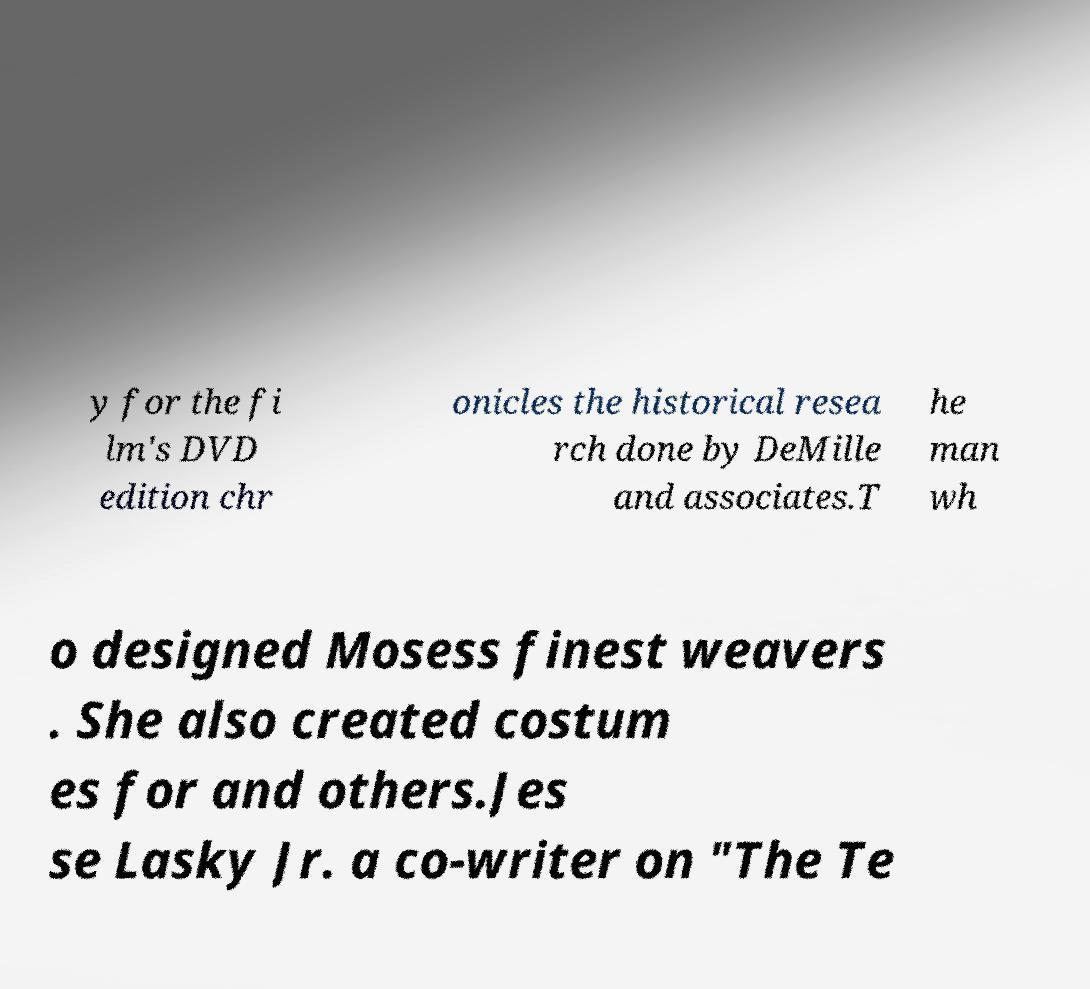Please identify and transcribe the text found in this image. y for the fi lm's DVD edition chr onicles the historical resea rch done by DeMille and associates.T he man wh o designed Mosess finest weavers . She also created costum es for and others.Jes se Lasky Jr. a co-writer on "The Te 